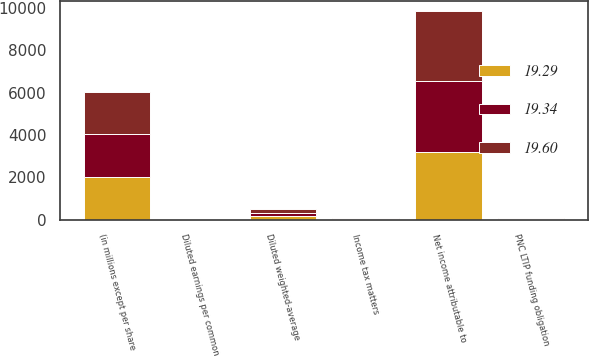Convert chart to OTSL. <chart><loc_0><loc_0><loc_500><loc_500><stacked_bar_chart><ecel><fcel>(in millions except per share<fcel>Net income attributable to<fcel>PNC LTIP funding obligation<fcel>Income tax matters<fcel>Diluted weighted-average<fcel>Diluted earnings per common<nl><fcel>19.29<fcel>2016<fcel>3214<fcel>19<fcel>30<fcel>166.6<fcel>19.29<nl><fcel>19.6<fcel>2015<fcel>3313<fcel>22<fcel>54<fcel>169<fcel>19.6<nl><fcel>19.34<fcel>2014<fcel>3310<fcel>25<fcel>9<fcel>171.1<fcel>19.34<nl></chart> 